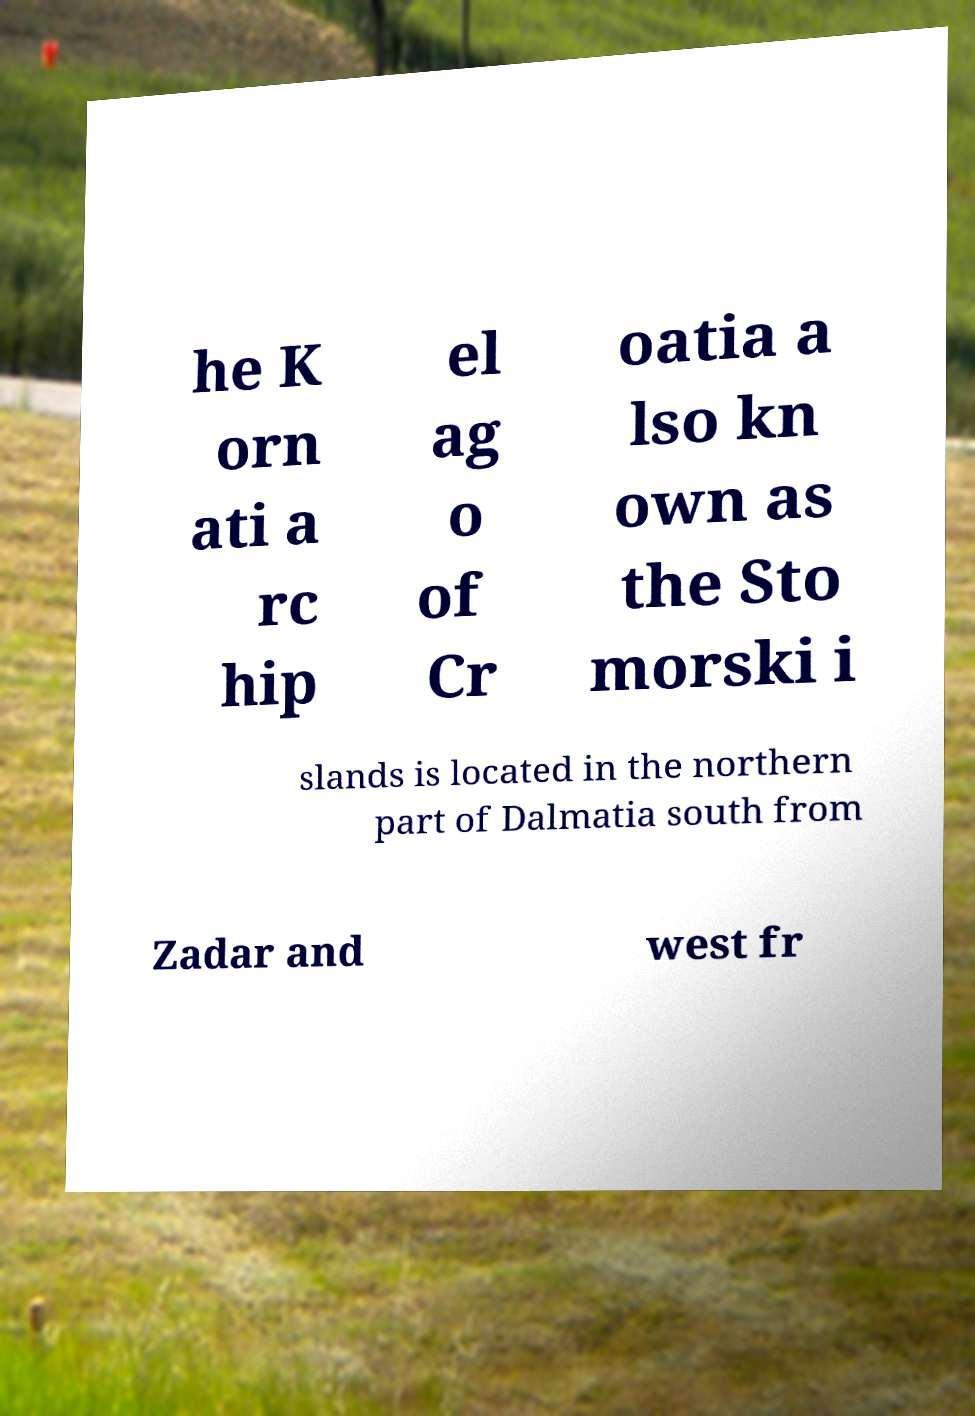Please identify and transcribe the text found in this image. he K orn ati a rc hip el ag o of Cr oatia a lso kn own as the Sto morski i slands is located in the northern part of Dalmatia south from Zadar and west fr 